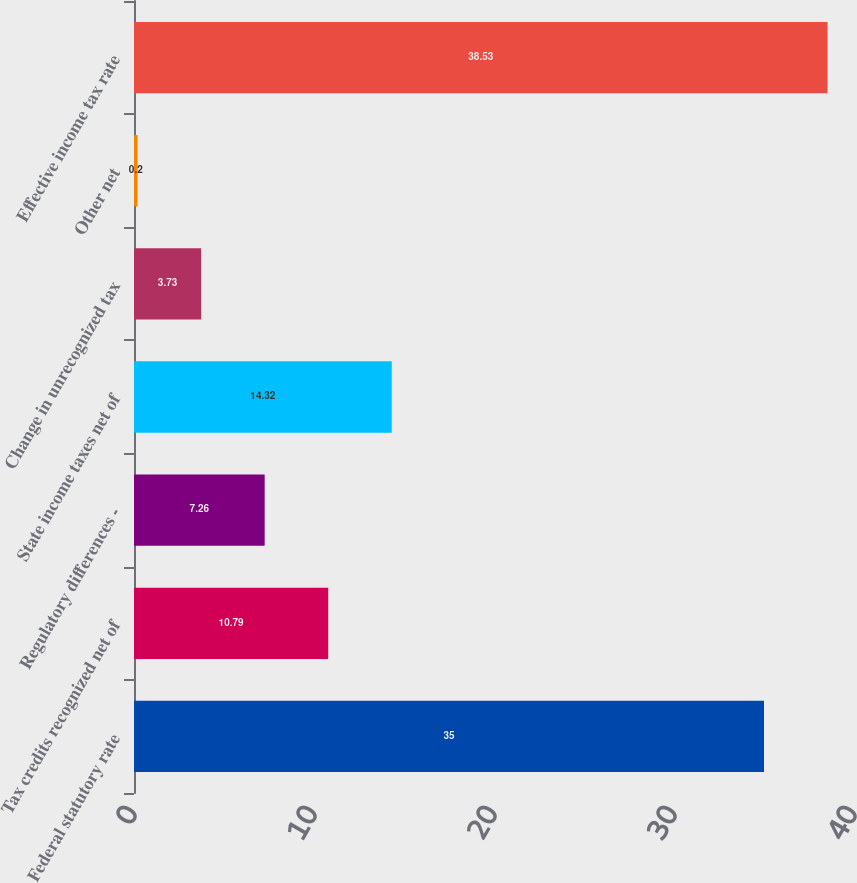Convert chart to OTSL. <chart><loc_0><loc_0><loc_500><loc_500><bar_chart><fcel>Federal statutory rate<fcel>Tax credits recognized net of<fcel>Regulatory differences -<fcel>State income taxes net of<fcel>Change in unrecognized tax<fcel>Other net<fcel>Effective income tax rate<nl><fcel>35<fcel>10.79<fcel>7.26<fcel>14.32<fcel>3.73<fcel>0.2<fcel>38.53<nl></chart> 